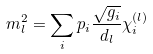Convert formula to latex. <formula><loc_0><loc_0><loc_500><loc_500>m _ { l } ^ { 2 } = \sum _ { i } p _ { i } \frac { \sqrt { g _ { i } } } { d _ { l } } \chi _ { i } ^ { ( l ) }</formula> 